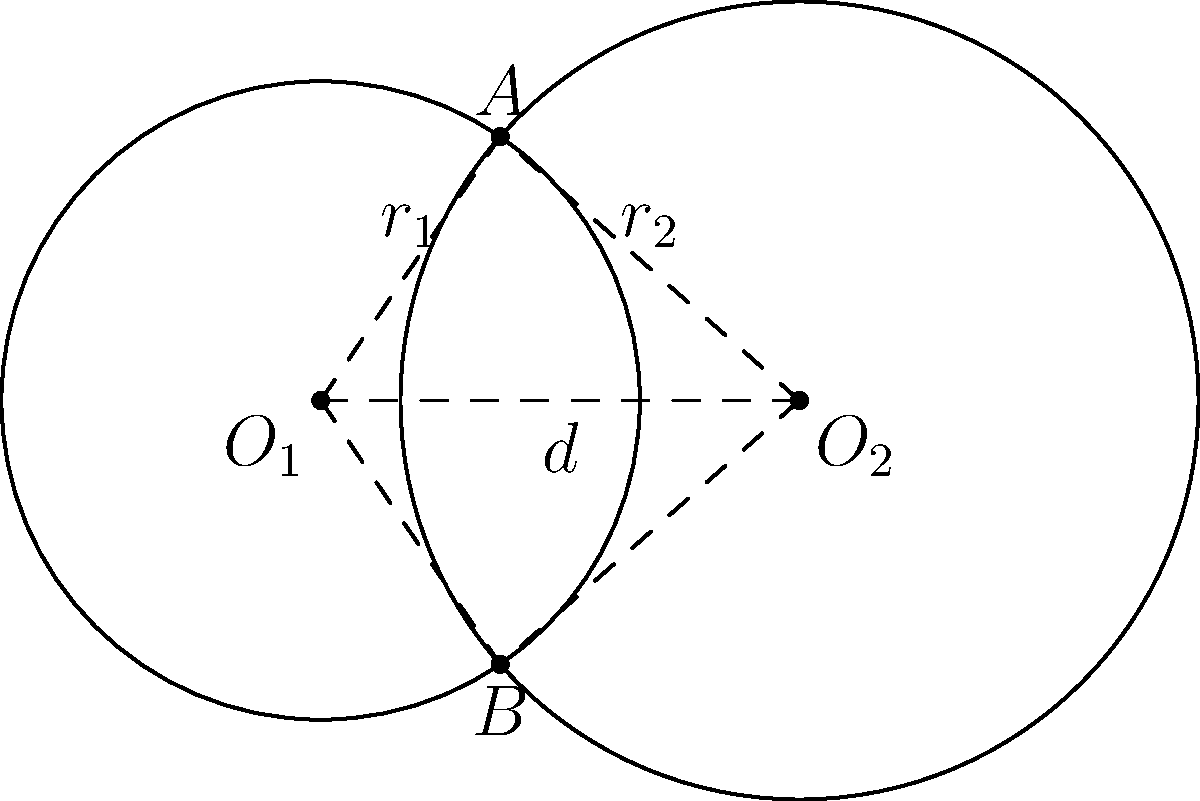In an AI-driven automated manufacturing process, two robotic arms with circular work areas overlap. The centers of these work areas are 3 units apart. One arm has a reach (radius) of 2 units, while the other has a reach of 2.5 units. Calculate the area of the overlapping region where both arms can operate simultaneously. Round your answer to two decimal places. To solve this problem, we'll use the formula for the area of the intersection of two circles. Let's approach this step-by-step:

1) First, we need to identify the key variables:
   $r_1 = 2$ (radius of the first circle)
   $r_2 = 2.5$ (radius of the second circle)
   $d = 3$ (distance between the centers)

2) The formula for the area of intersection is:

   $$A = r_1^2 \arccos(\frac{d^2 + r_1^2 - r_2^2}{2dr_1}) + r_2^2 \arccos(\frac{d^2 + r_2^2 - r_1^2}{2dr_2}) - \frac{1}{2}\sqrt{(-d+r_1+r_2)(d+r_1-r_2)(d-r_1+r_2)(d+r_1+r_2)}$$

3) Let's calculate each part separately:

   Part 1: $r_1^2 \arccos(\frac{d^2 + r_1^2 - r_2^2}{2dr_1})$
   $= 4 \arccos(\frac{3^2 + 2^2 - 2.5^2}{2 \cdot 3 \cdot 2}) = 4 \arccos(0.0833) = 3.9588$

   Part 2: $r_2^2 \arccos(\frac{d^2 + r_2^2 - r_1^2}{2dr_2})$
   $= 6.25 \arccos(\frac{3^2 + 2.5^2 - 2^2}{2 \cdot 3 \cdot 2.5}) = 6.25 \arccos(0.5667) = 3.2488$

   Part 3: $\frac{1}{2}\sqrt{(-d+r_1+r_2)(d+r_1-r_2)(d-r_1+r_2)(d+r_1+r_2)}$
   $= \frac{1}{2}\sqrt{(1.5)(2.5)(3.5)(7.5)} = 2.7204$

4) Now, we can put it all together:
   $A = 3.9588 + 3.2488 - 2.7204 = 4.4872$

5) Rounding to two decimal places: 4.49
Answer: 4.49 square units 